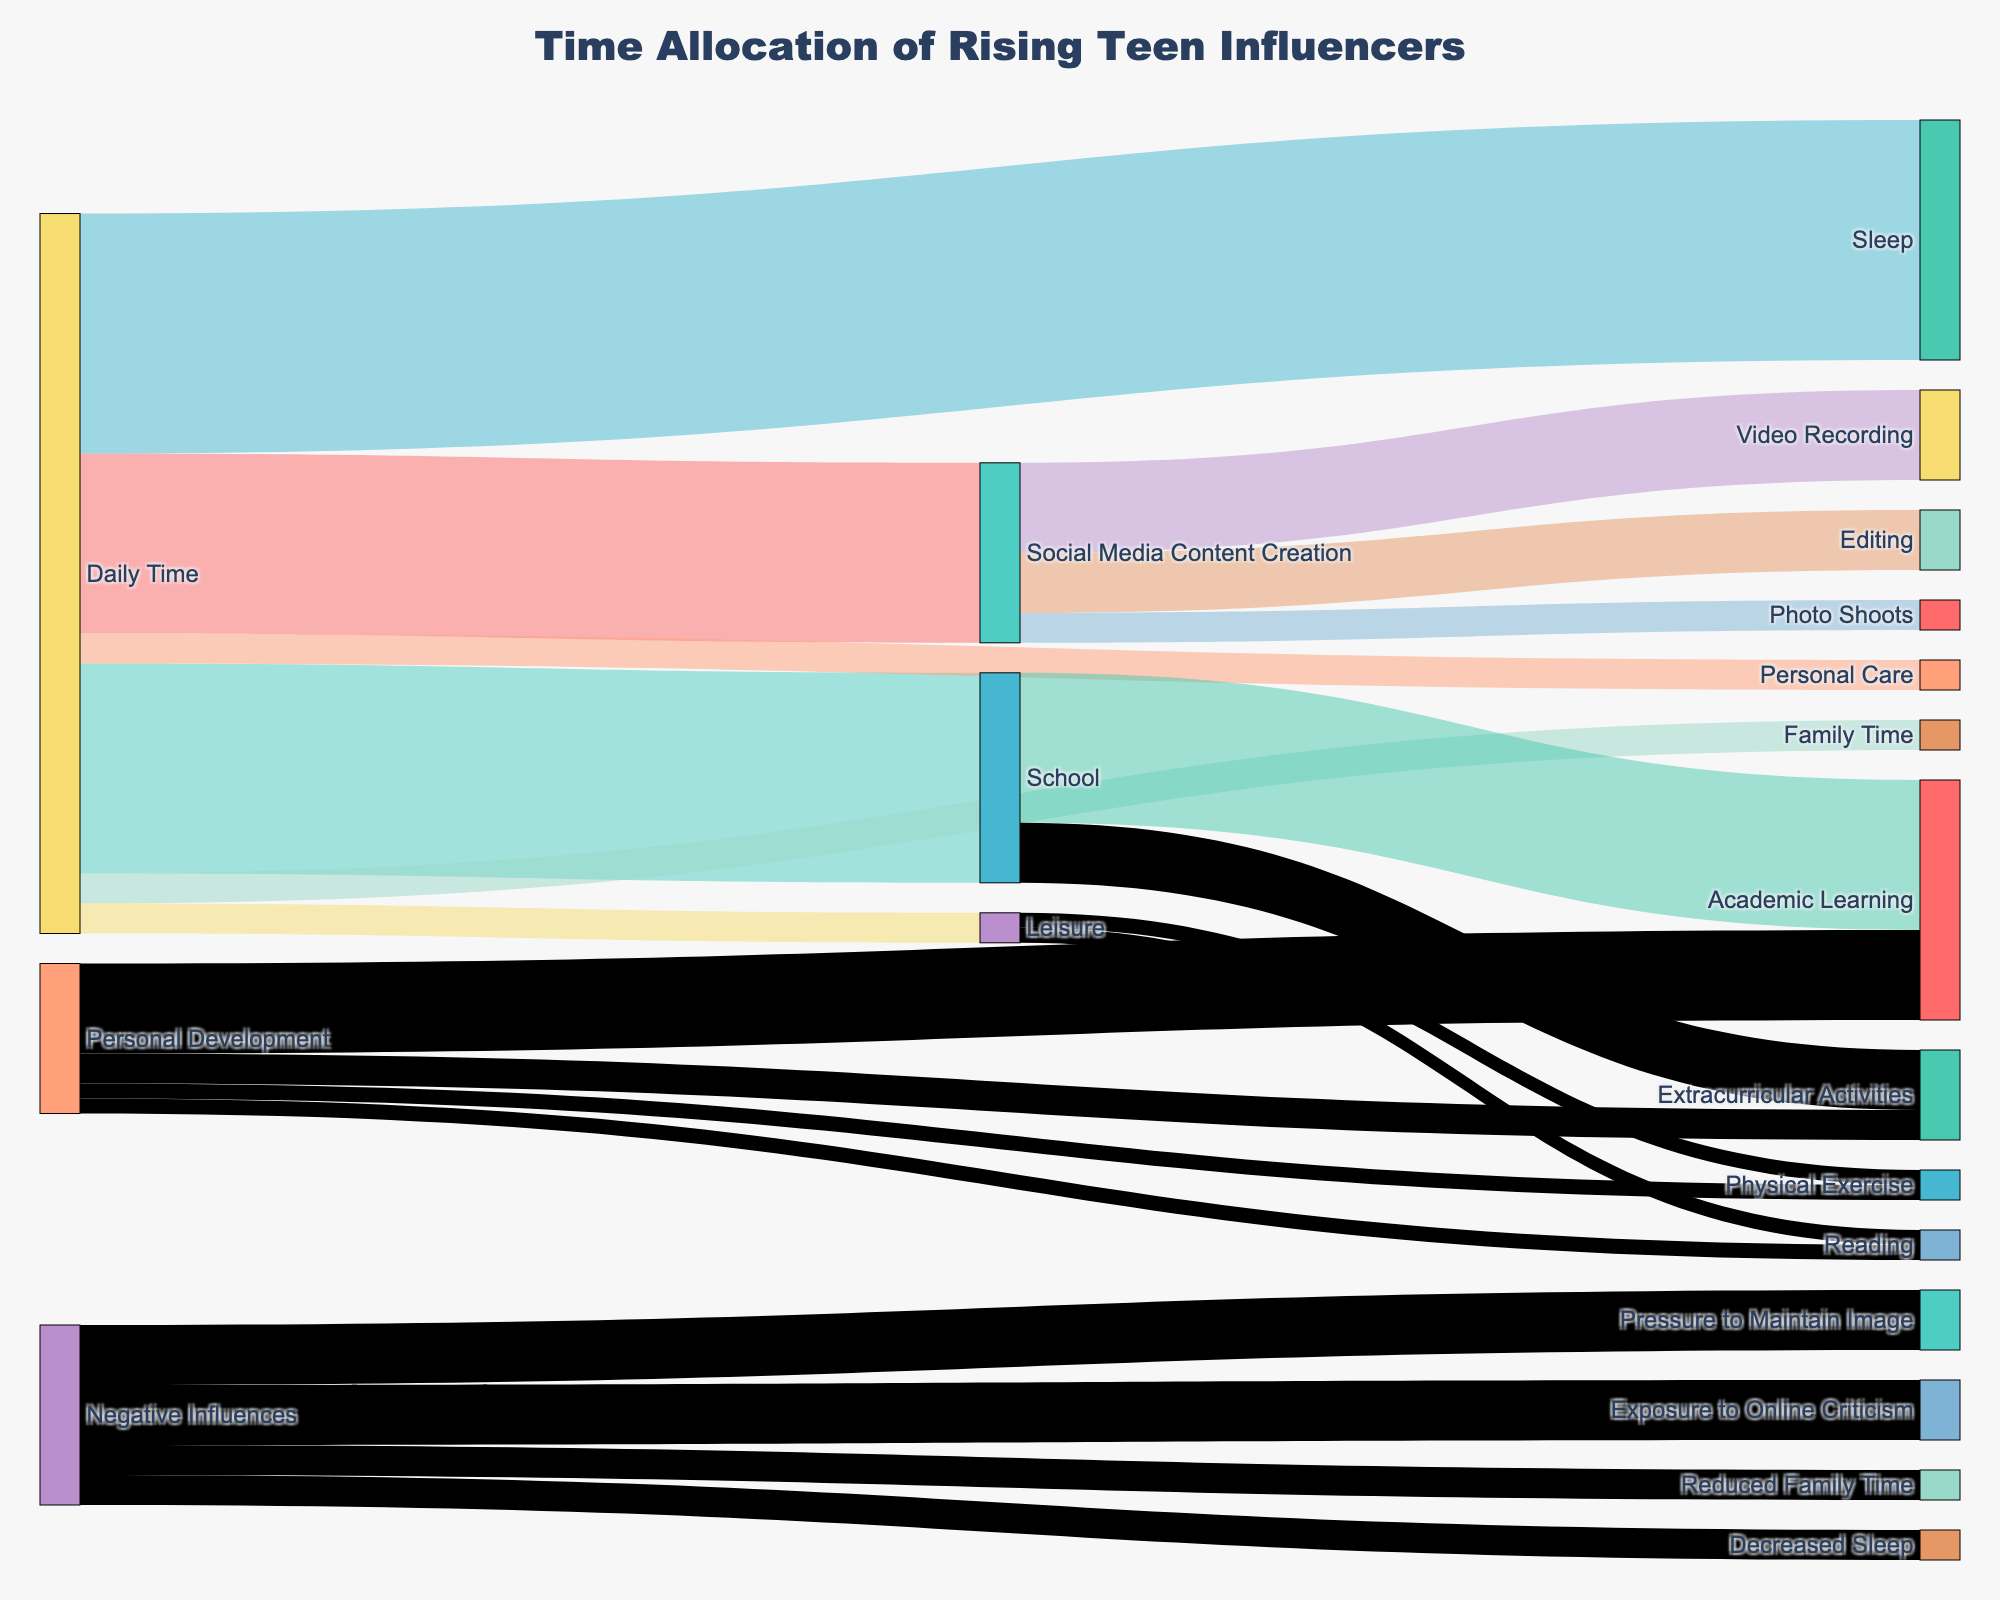What is the total daily time allocated to Social Media Content Creation? Identify the flow from 'Daily Time' to 'Social Media Content Creation' and note the value associated with this connection.
Answer: 6 hours How much time is spent on Video Recording within Social Media Content Creation? Observe the flow from 'Social Media Content Creation' to 'Video Recording' and note the value provided.
Answer: 3 hours How does the time spent on Personal Care compare to Family Time? Compare the values connected to 'Daily Time' for both 'Personal Care' and 'Family Time'. Both have the same value of 1 hour each.
Answer: Equal (1 hour each) What proportion of the total daily time is dedicated to sleep? Identify the total daily time spent (24 hours) and the connection value from 'Daily Time' to 'Sleep' (8 hours). The proportion is calculated as 8/24.
Answer: 1/3 (or 33.3%) How much time in total is allocated to activities that contribute to Personal Development? Sum the values for 'Academic Learning' (3 hours), 'Extracurricular Activities' (1 hour), 'Reading' (0.5 hours), and 'Physical Exercise' (0.5 hours) under 'Personal Development'.
Answer: 5 hours Which activity under Social Media Content Creation consumes the most time? Compare the values for 'Video Recording' (3 hours), 'Photo Shoots' (1 hour), and 'Editing' (2 hours). 'Video Recording' has the highest value.
Answer: Video Recording (3 hours) How much time, if any, is not accounted for by the activities listed under 'Daily Time'? Verify that the total time allocated in 'Daily Time' adds up to 24 hours (6+7+8+1+1+1). Any discrepancy would indicate unaccounted time.
Answer: None (total is 24 hours) What negative influences are associated with social media activities and their total impact time? Identify connections leading to 'Negative Influences' and note the total impact time (add time values connected to negative influences). 'Reduced Family Time' (1 hour), 'Decreased Sleep' (1 hour), 'Pressure to Maintain Image' (2 hours), 'Exposure to Online Criticism' (2 hours).
Answer: 6 hours 